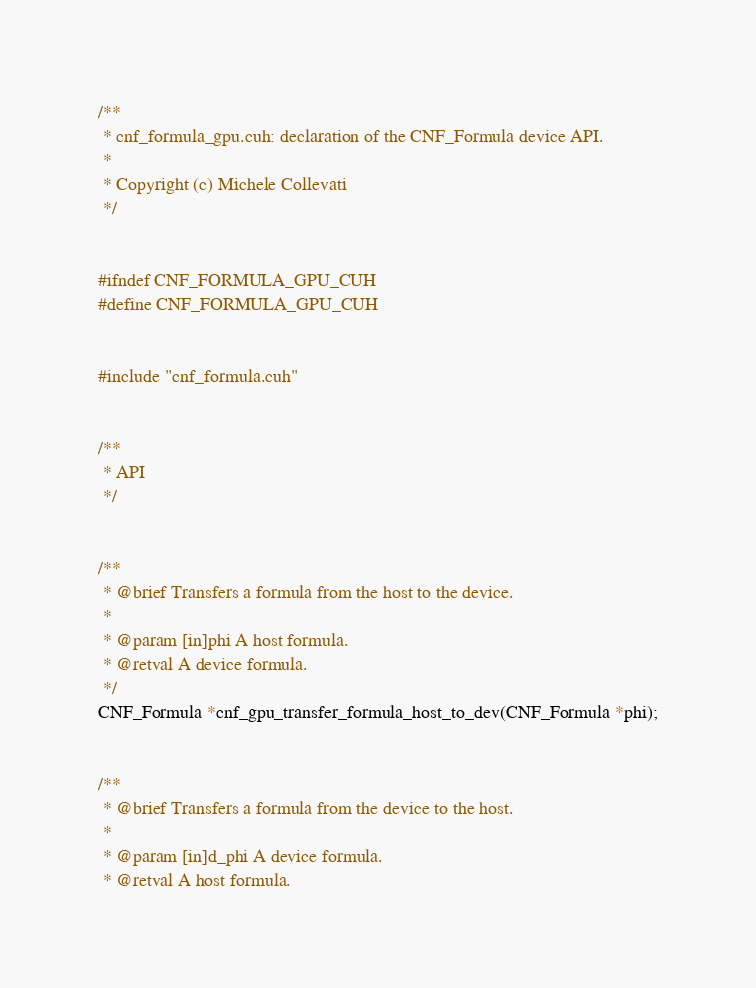Convert code to text. <code><loc_0><loc_0><loc_500><loc_500><_Cuda_>/**
 * cnf_formula_gpu.cuh: declaration of the CNF_Formula device API.
 * 
 * Copyright (c) Michele Collevati
 */


#ifndef CNF_FORMULA_GPU_CUH
#define CNF_FORMULA_GPU_CUH


#include "cnf_formula.cuh"


/**
 * API
 */


/**
 * @brief Transfers a formula from the host to the device.
 * 
 * @param [in]phi A host formula.
 * @retval A device formula.
 */
CNF_Formula *cnf_gpu_transfer_formula_host_to_dev(CNF_Formula *phi);


/**
 * @brief Transfers a formula from the device to the host.
 * 
 * @param [in]d_phi A device formula.
 * @retval A host formula.</code> 